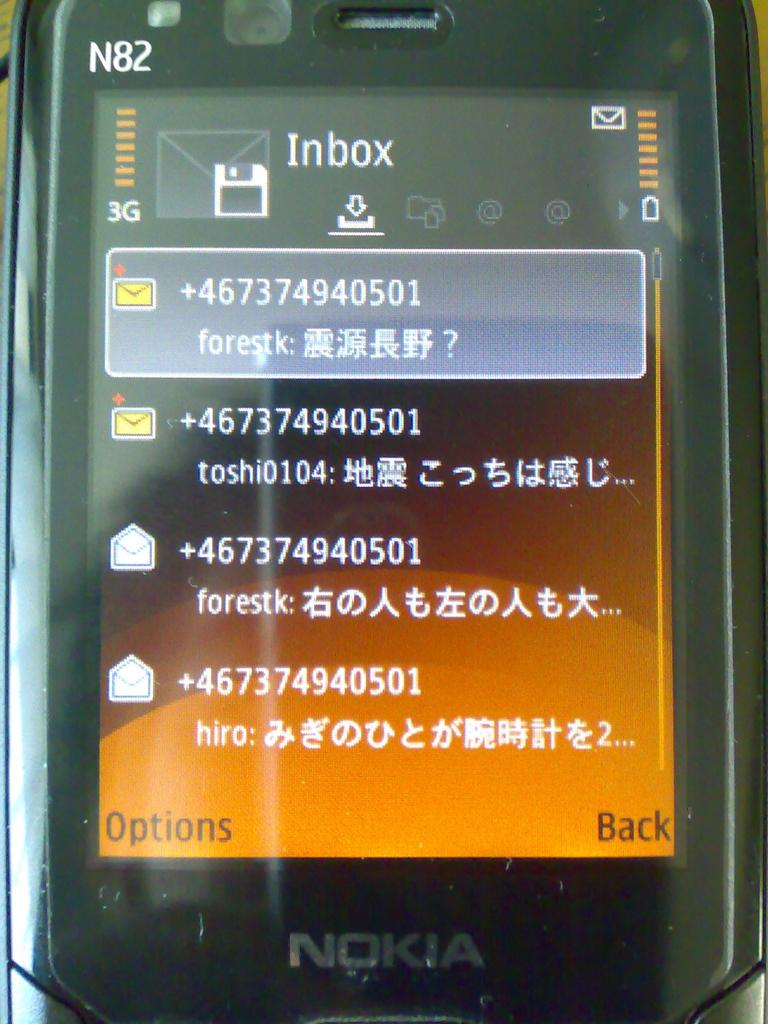<image>
Relay a brief, clear account of the picture shown. A NOKIA phone showing four Inbox mail messages. 